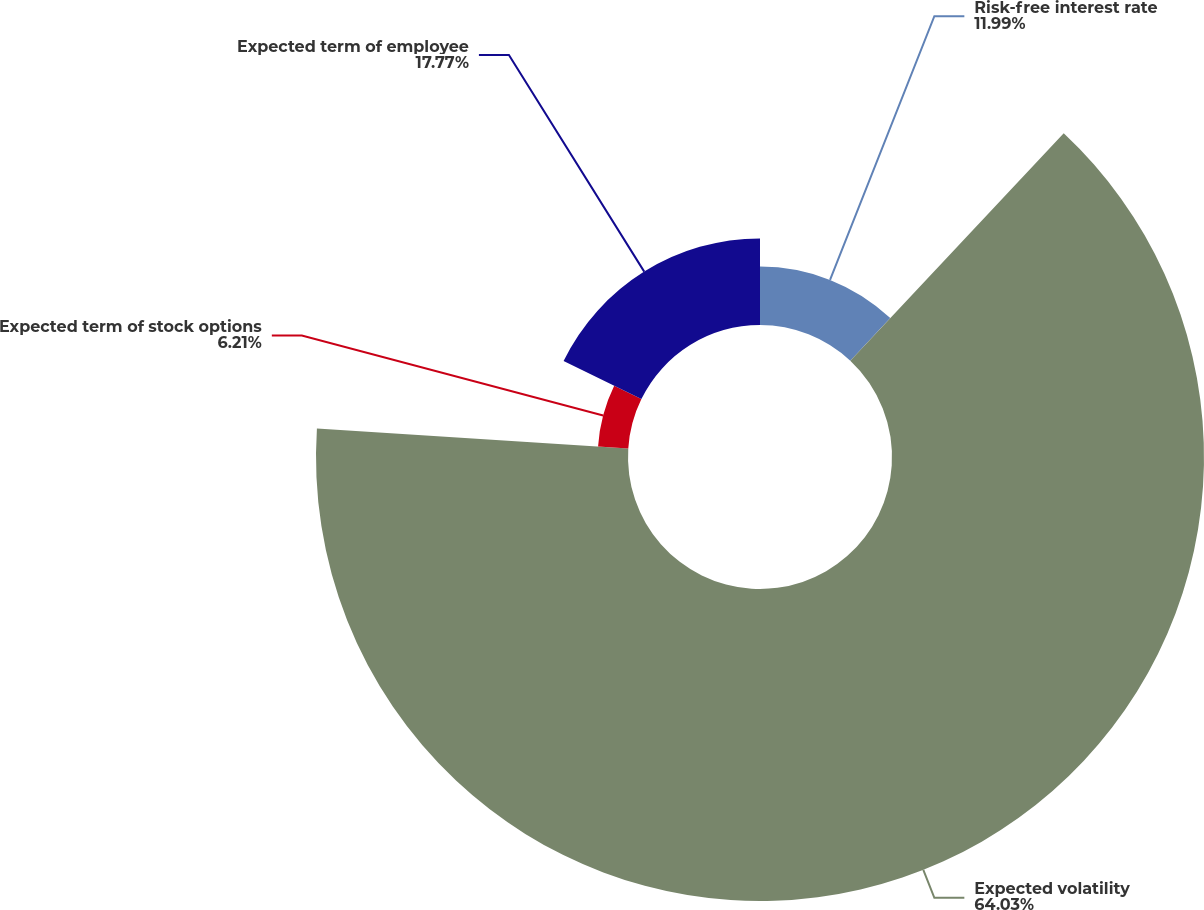Convert chart to OTSL. <chart><loc_0><loc_0><loc_500><loc_500><pie_chart><fcel>Risk-free interest rate<fcel>Expected volatility<fcel>Expected term of stock options<fcel>Expected term of employee<nl><fcel>11.99%<fcel>64.03%<fcel>6.21%<fcel>17.77%<nl></chart> 